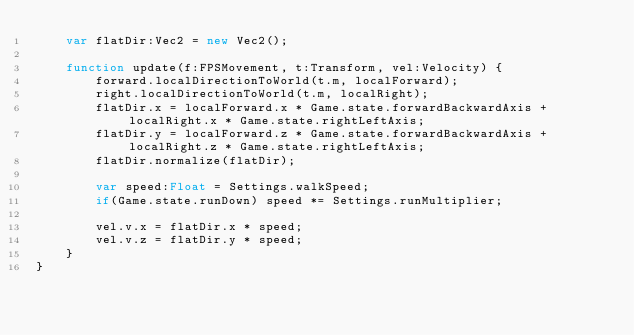Convert code to text. <code><loc_0><loc_0><loc_500><loc_500><_Haxe_>    var flatDir:Vec2 = new Vec2();

    function update(f:FPSMovement, t:Transform, vel:Velocity) {
        forward.localDirectionToWorld(t.m, localForward);
        right.localDirectionToWorld(t.m, localRight);
        flatDir.x = localForward.x * Game.state.forwardBackwardAxis + localRight.x * Game.state.rightLeftAxis;
        flatDir.y = localForward.z * Game.state.forwardBackwardAxis + localRight.z * Game.state.rightLeftAxis;
        flatDir.normalize(flatDir);

        var speed:Float = Settings.walkSpeed;
        if(Game.state.runDown) speed *= Settings.runMultiplier;

        vel.v.x = flatDir.x * speed;
        vel.v.z = flatDir.y * speed;
    }
}
</code> 